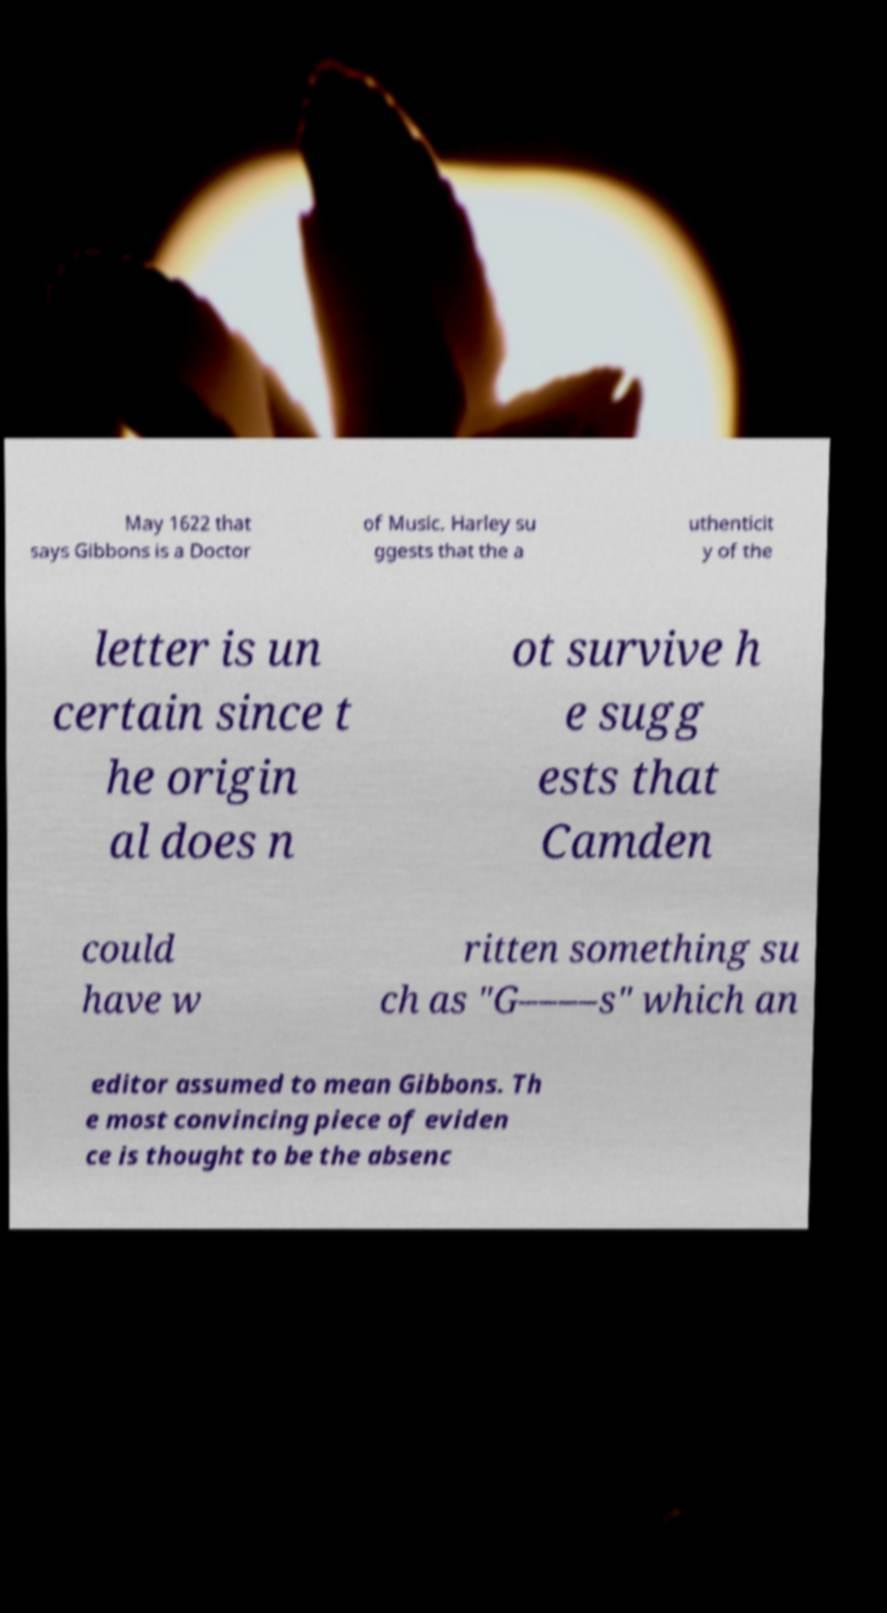Can you read and provide the text displayed in the image?This photo seems to have some interesting text. Can you extract and type it out for me? May 1622 that says Gibbons is a Doctor of Music. Harley su ggests that the a uthenticit y of the letter is un certain since t he origin al does n ot survive h e sugg ests that Camden could have w ritten something su ch as "G––––s" which an editor assumed to mean Gibbons. Th e most convincing piece of eviden ce is thought to be the absenc 